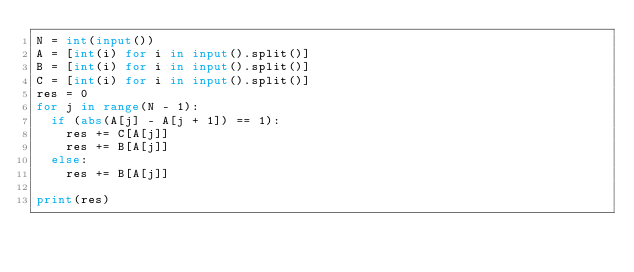Convert code to text. <code><loc_0><loc_0><loc_500><loc_500><_Python_>N = int(input())
A = [int(i) for i in input().split()]
B = [int(i) for i in input().split()]
C = [int(i) for i in input().split()]
res = 0
for j in range(N - 1):
  if (abs(A[j] - A[j + 1]) == 1):
    res += C[A[j]]
    res += B[A[j]]
  else:
    res += B[A[j]]
    
print(res)</code> 